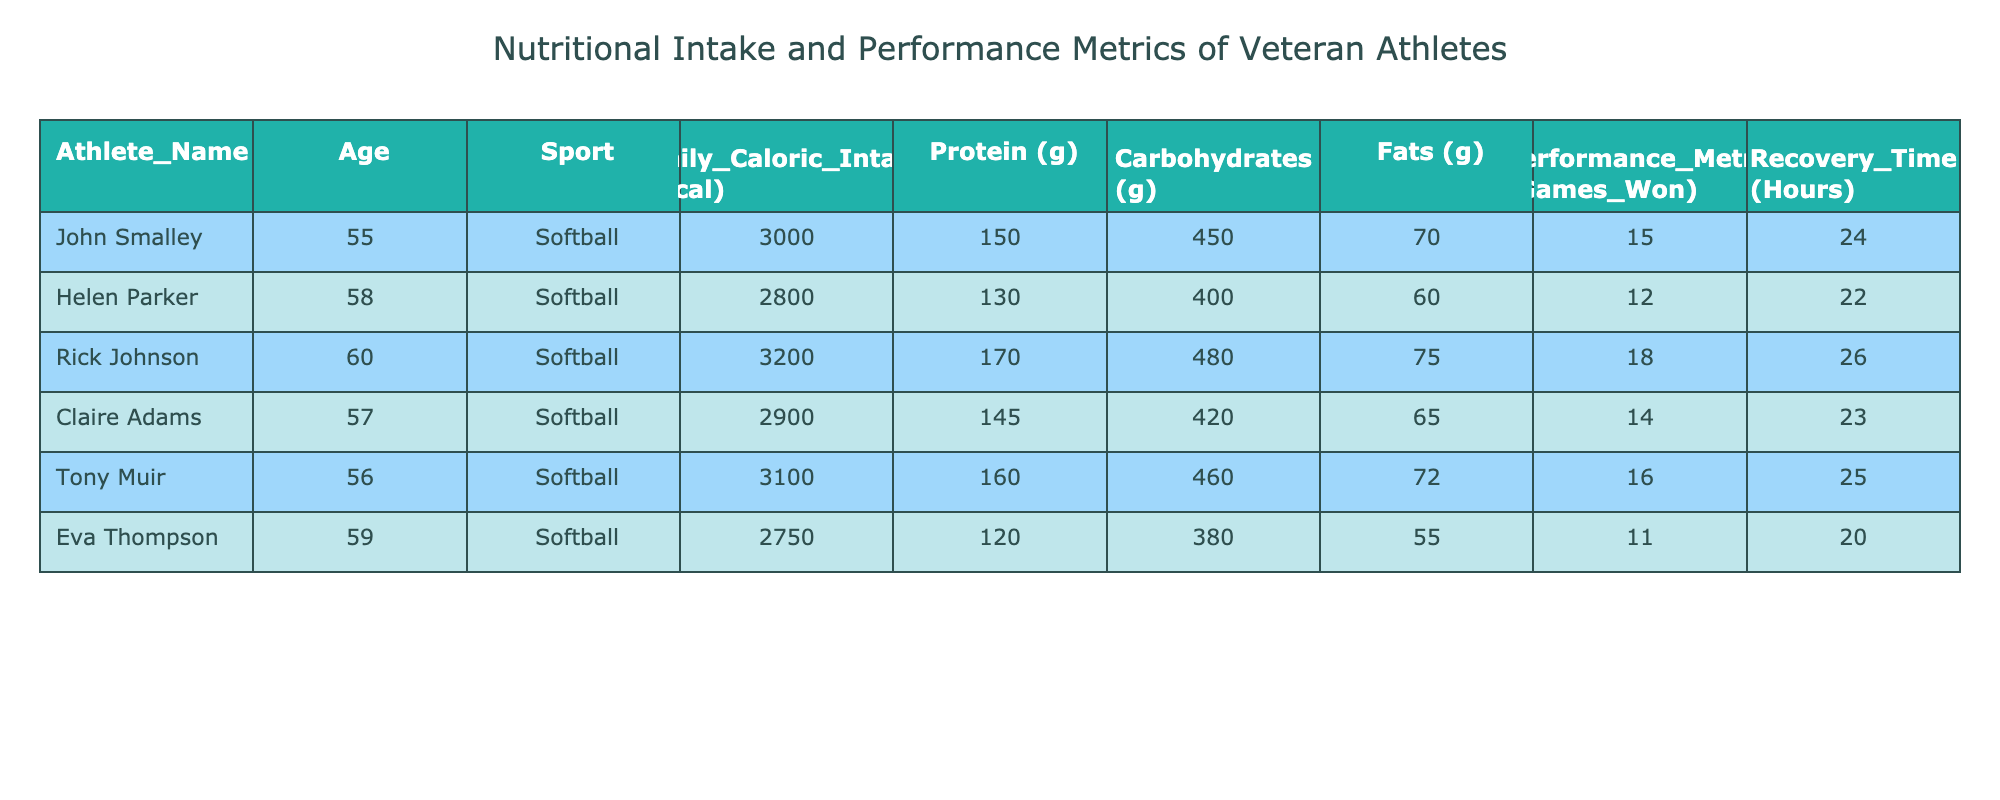What is the total daily caloric intake of all athletes combined? To find the total caloric intake, we add together the daily caloric intake of each athlete: 3000 + 2800 + 3200 + 2900 + 3100 + 2750 = 17750 kcal.
Answer: 17750 kcal Which athlete has the highest protein intake? Looking at the protein column, Rick Johnson has the highest protein intake with 170 grams.
Answer: Rick Johnson Is Eva Thompson's recovery time greater than 20 hours? Eva Thompson's recovery time is 20 hours, which is not greater than 20. Therefore, the statement is false.
Answer: No What is the average performance metric (games won) of the athletes? To calculate the average, we sum the games won (15 + 12 + 18 + 14 + 16 + 11 = 86) and divide by the number of athletes (6): 86 / 6 = 14.33.
Answer: 14.33 Is it true that athletes with higher daily caloric intake also have higher performance metrics? The highest daily caloric intake is 3200 kcal (Rick Johnson) and he won 18 games. The lowest intake is 2750 kcal (Eva Thompson) who won 11 games. However, the relationship is not strictly linear as not all higher intake correlates with higher performance metrics. Thus, the statement is false.
Answer: No What is the difference between the protein intake of the athlete with the highest and lowest intake? Rick Johnson has the highest protein intake at 170 grams and Eva Thompson has the lowest at 120 grams. The difference is 170 - 120 = 50 grams.
Answer: 50 grams Which athlete has a balanced distribution of macronutrients (carbohydrates, fats, and proteins)? Looking at the ratios of the macronutrients from the table, John Smalley has close values: 150g protein, 450g carbohydrates, and 70g fats, indicating a relatively balanced intake compared to others.
Answer: John Smalley What is the total recovery time for all athletes combined? To find the total recovery time, we add the recovery times: 24 + 22 + 26 + 23 + 25 + 20 = 140 hours.
Answer: 140 hours Is there an athlete whose daily caloric intake is exactly 2900 kcal? Yes, Claire Adams has a daily caloric intake of exactly 2900 kcal.
Answer: Yes 